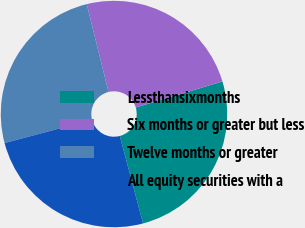Convert chart. <chart><loc_0><loc_0><loc_500><loc_500><pie_chart><fcel>Lessthansixmonths<fcel>Six months or greater but less<fcel>Twelve months or greater<fcel>All equity securities with a<nl><fcel>25.51%<fcel>24.23%<fcel>25.26%<fcel>25.0%<nl></chart> 